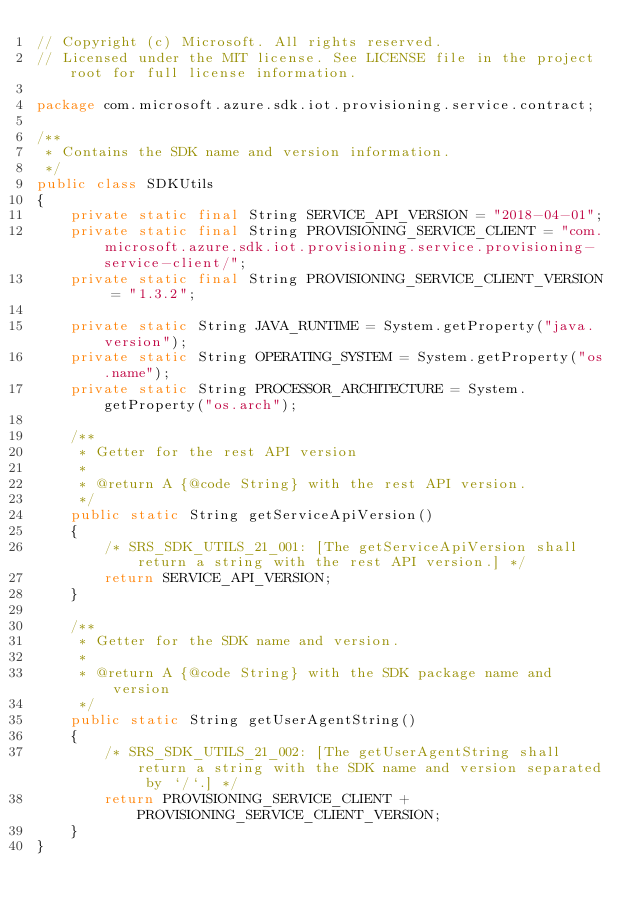Convert code to text. <code><loc_0><loc_0><loc_500><loc_500><_Java_>// Copyright (c) Microsoft. All rights reserved.
// Licensed under the MIT license. See LICENSE file in the project root for full license information.

package com.microsoft.azure.sdk.iot.provisioning.service.contract;

/**
 * Contains the SDK name and version information.
 */
public class SDKUtils
{
    private static final String SERVICE_API_VERSION = "2018-04-01";
    private static final String PROVISIONING_SERVICE_CLIENT = "com.microsoft.azure.sdk.iot.provisioning.service.provisioning-service-client/";
    private static final String PROVISIONING_SERVICE_CLIENT_VERSION = "1.3.2";

    private static String JAVA_RUNTIME = System.getProperty("java.version");
    private static String OPERATING_SYSTEM = System.getProperty("os.name");
    private static String PROCESSOR_ARCHITECTURE = System.getProperty("os.arch");

    /**
     * Getter for the rest API version
     *
     * @return A {@code String} with the rest API version.
     */
    public static String getServiceApiVersion()
    {
        /* SRS_SDK_UTILS_21_001: [The getServiceApiVersion shall return a string with the rest API version.] */
        return SERVICE_API_VERSION;
    }

    /**
     * Getter for the SDK name and version.
     *
     * @return A {@code String} with the SDK package name and version
     */
    public static String getUserAgentString()
    {
        /* SRS_SDK_UTILS_21_002: [The getUserAgentString shall return a string with the SDK name and version separated by `/`.] */
        return PROVISIONING_SERVICE_CLIENT + PROVISIONING_SERVICE_CLIENT_VERSION;
    }
}
</code> 